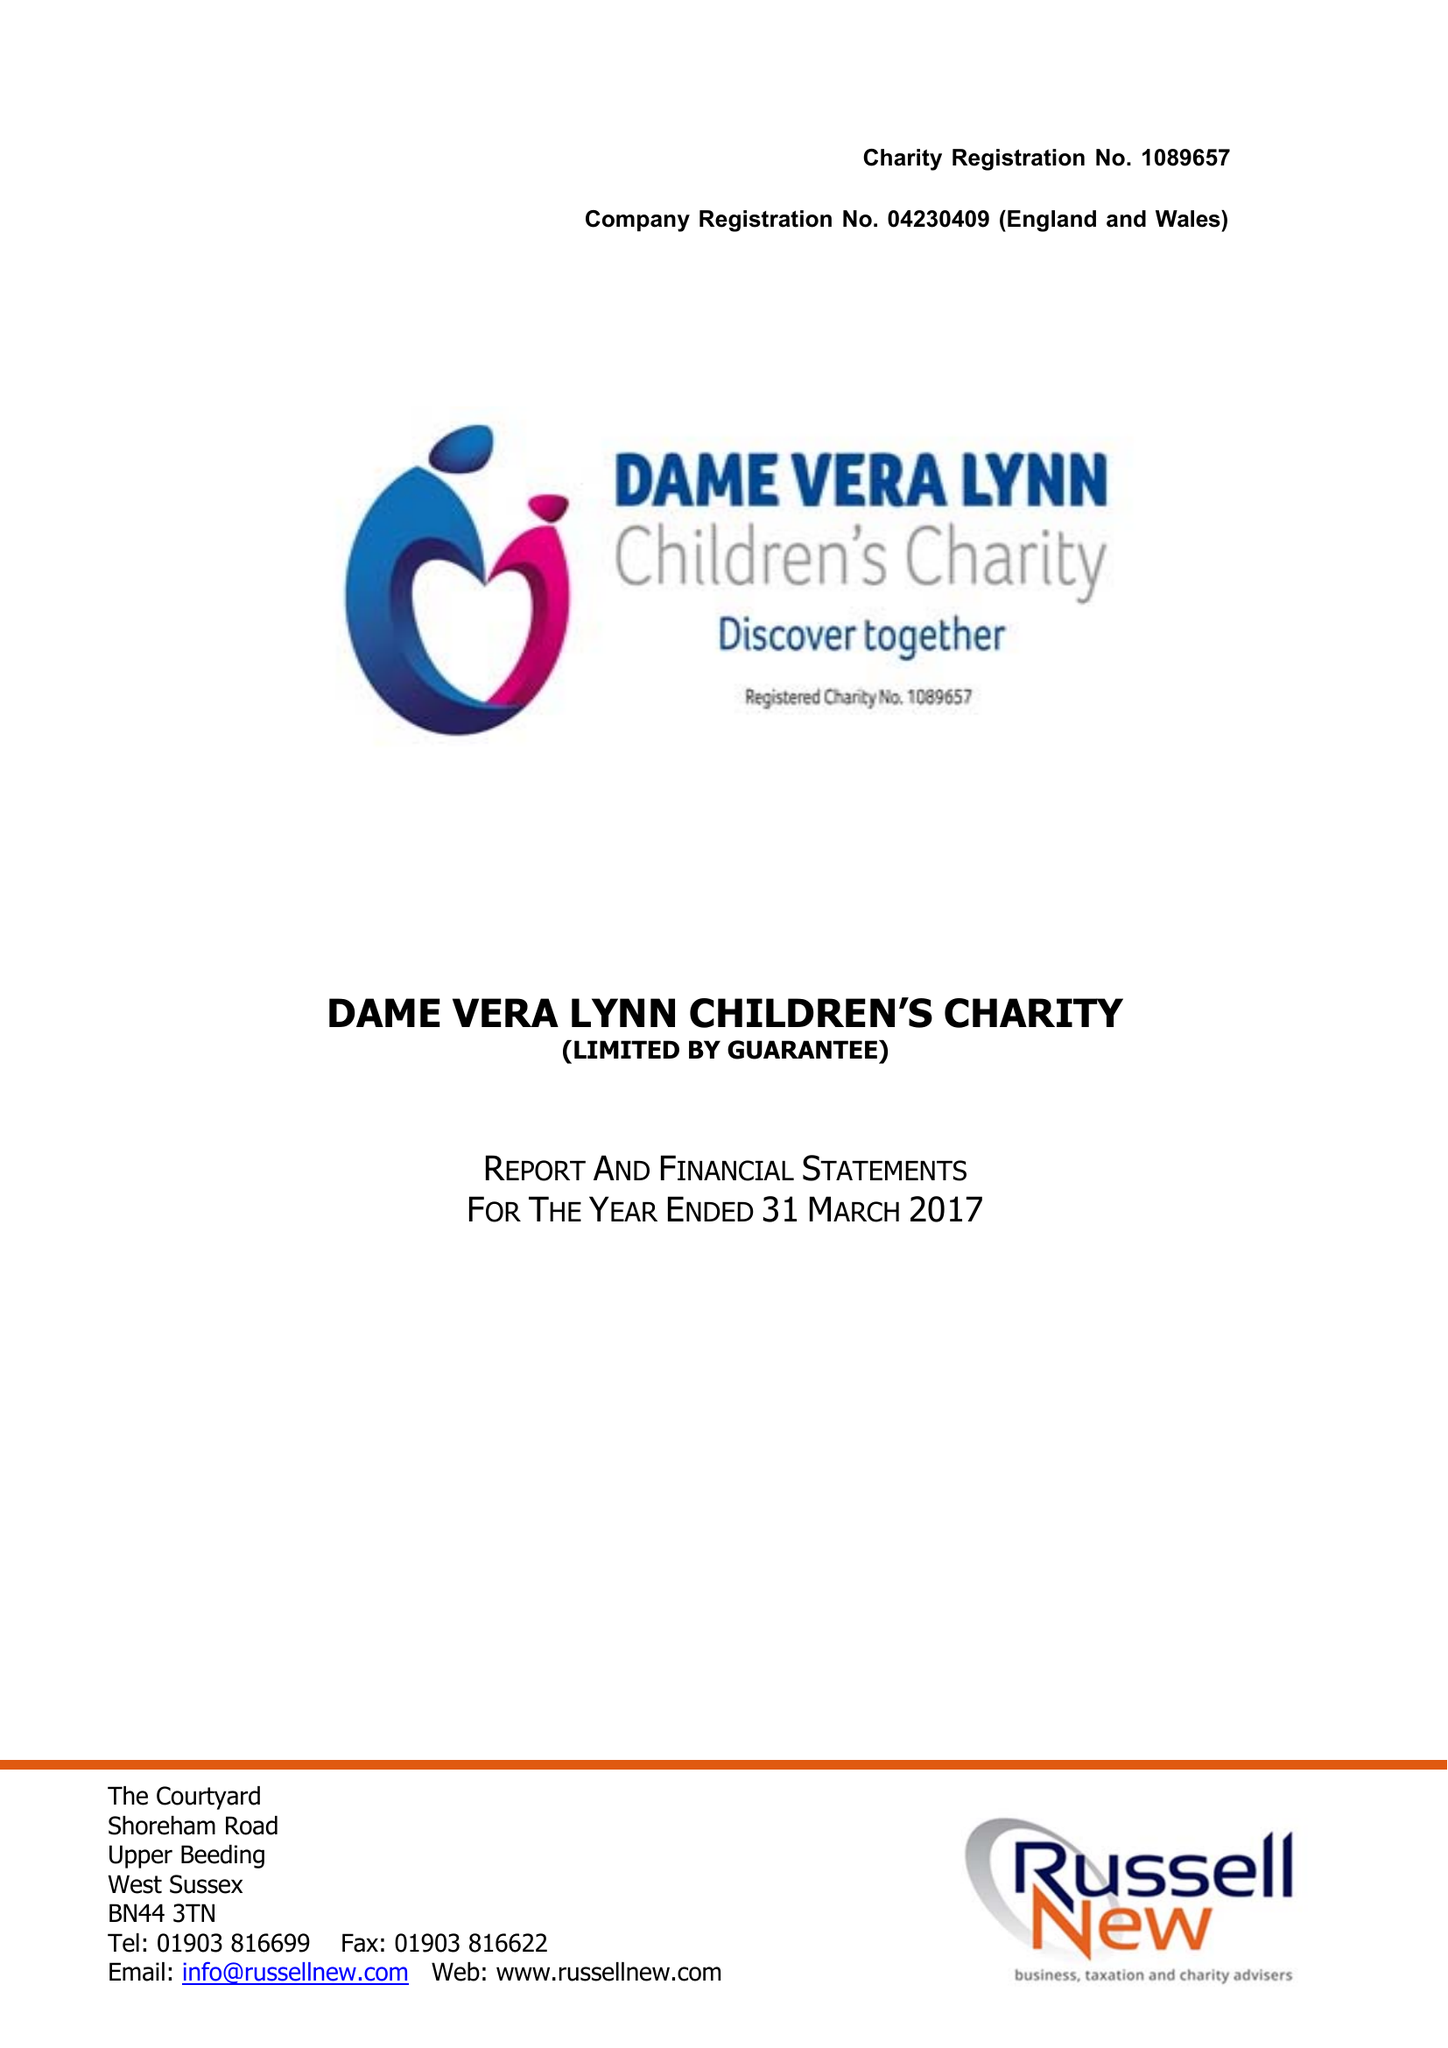What is the value for the address__postcode?
Answer the question using a single word or phrase. RH17 5JF 